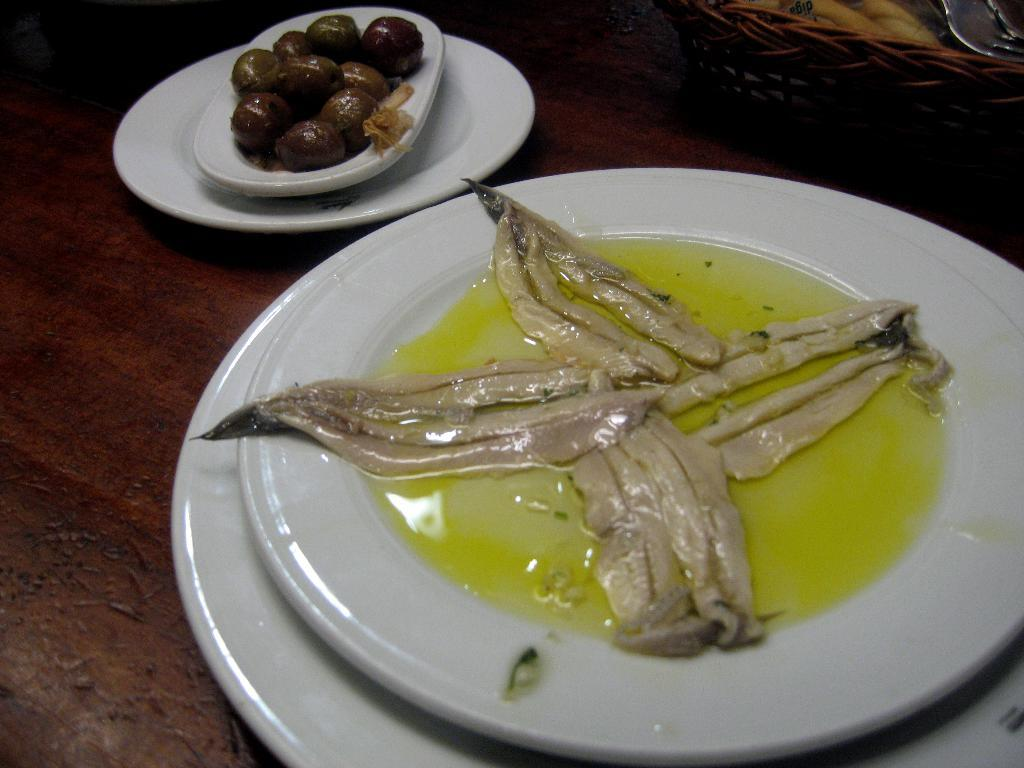What can be seen on the table in the image? There are food plates on the table in the image. What types of food are on the plates? There are two different food items on the plates. Where are the plates located in relation to the table? The plates are on the table. What is present in the top right corner of the image? There is a basket in the top right corner of the image. How many giants can be seen walking through the window in the image? There are no giants or windows present in the image. 